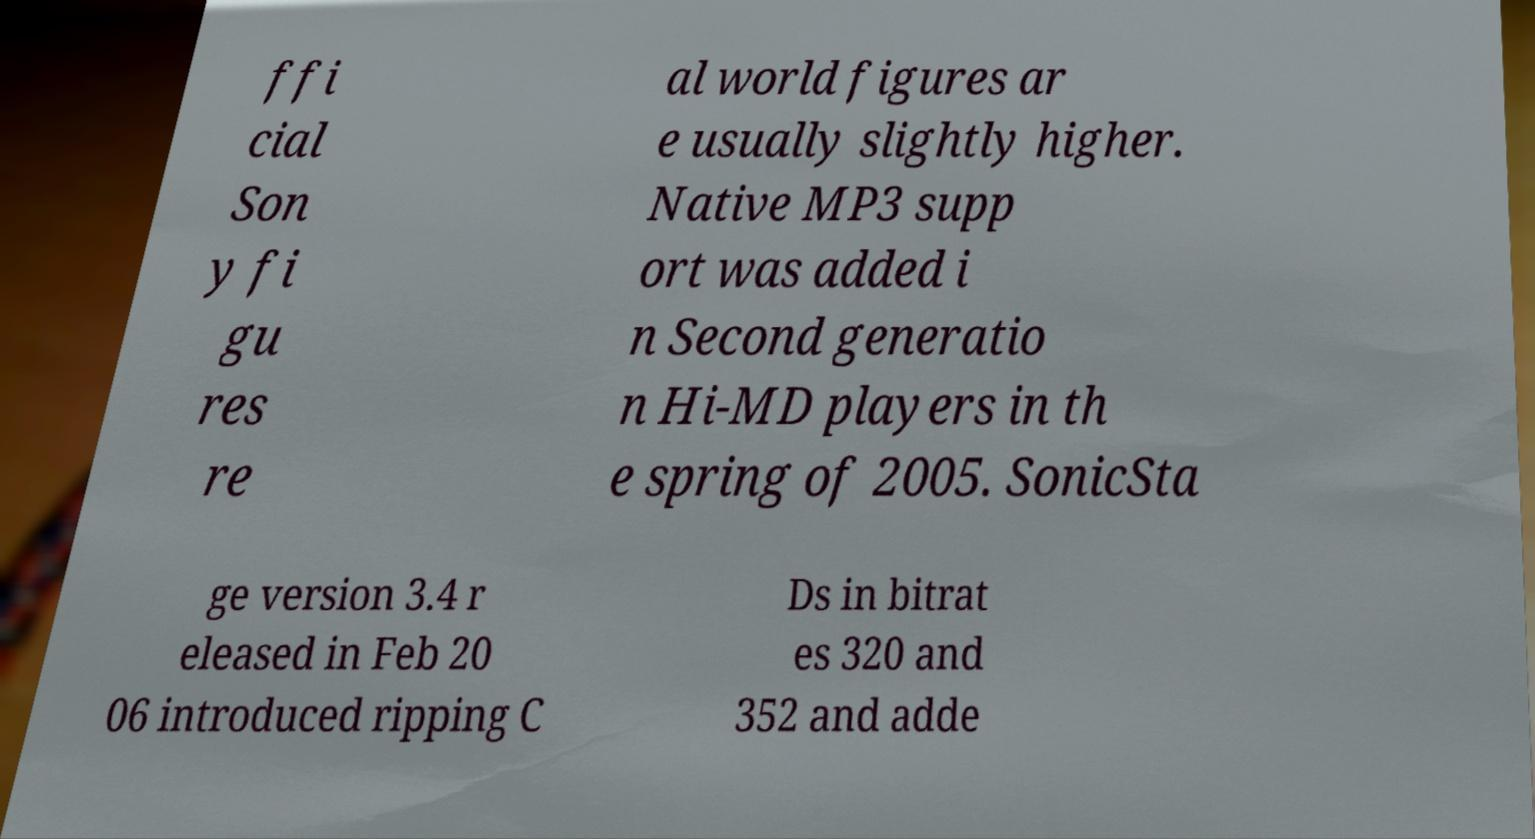What messages or text are displayed in this image? I need them in a readable, typed format. ffi cial Son y fi gu res re al world figures ar e usually slightly higher. Native MP3 supp ort was added i n Second generatio n Hi-MD players in th e spring of 2005. SonicSta ge version 3.4 r eleased in Feb 20 06 introduced ripping C Ds in bitrat es 320 and 352 and adde 